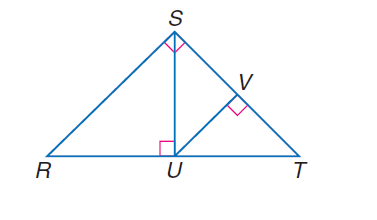Answer the mathemtical geometry problem and directly provide the correct option letter.
Question: If \angle R S T is a right angle, S U \perp R T, U V \perp S T, and m \angle R T S = 47, find m \angle S U V.
Choices: A: 47 B: 53 C: 55 D: 66 A 